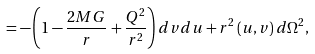<formula> <loc_0><loc_0><loc_500><loc_500>= - \left ( 1 - \frac { 2 M G } { r } + \frac { Q ^ { 2 } } { r ^ { 2 } } \right ) d v d u + r ^ { 2 } \left ( u , v \right ) d \Omega ^ { 2 } ,</formula> 